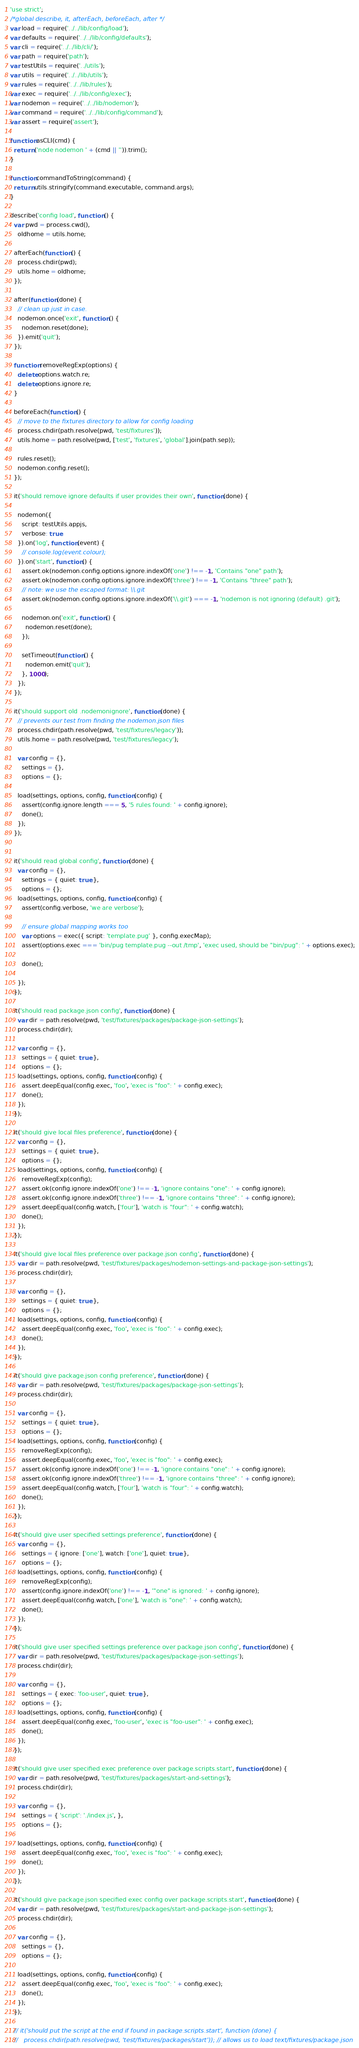Convert code to text. <code><loc_0><loc_0><loc_500><loc_500><_JavaScript_>'use strict';
/*global describe, it, afterEach, beforeEach, after */
var load = require('../../lib/config/load');
var defaults = require('../../lib/config/defaults');
var cli = require('../../lib/cli/');
var path = require('path');
var testUtils = require('../utils');
var utils = require('../../lib/utils');
var rules = require('../../lib/rules');
var exec = require('../../lib/config/exec');
var nodemon = require('../../lib/nodemon');
var command = require('../../lib/config/command');
var assert = require('assert');

function asCLI(cmd) {
  return ('node nodemon ' + (cmd || '')).trim();
}

function commandToString(command) {
  return utils.stringify(command.executable, command.args);
}

describe('config load', function () {
  var pwd = process.cwd(),
    oldhome = utils.home;

  afterEach(function () {
    process.chdir(pwd);
    utils.home = oldhome;
  });

  after(function (done) {
    // clean up just in case.
    nodemon.once('exit', function () {
      nodemon.reset(done);
    }).emit('quit');
  });

  function removeRegExp(options) {
    delete options.watch.re;
    delete options.ignore.re;
  }

  beforeEach(function () {
    // move to the fixtures directory to allow for config loading
    process.chdir(path.resolve(pwd, 'test/fixtures'));
    utils.home = path.resolve(pwd, ['test', 'fixtures', 'global'].join(path.sep));

    rules.reset();
    nodemon.config.reset();
  });

  it('should remove ignore defaults if user provides their own', function (done) {

    nodemon({
      script: testUtils.appjs,
      verbose: true
    }).on('log', function (event) {
      // console.log(event.colour);
    }).on('start', function () {
      assert.ok(nodemon.config.options.ignore.indexOf('one') !== -1, 'Contains "one" path');
      assert.ok(nodemon.config.options.ignore.indexOf('three') !== -1, 'Contains "three" path');
      // note: we use the escaped format: \\.git
      assert.ok(nodemon.config.options.ignore.indexOf('\\.git') === -1, 'nodemon is not ignoring (default) .git');

      nodemon.on('exit', function () {
        nodemon.reset(done);
      });

      setTimeout(function () {
        nodemon.emit('quit');
      }, 1000);
    });
  });

  it('should support old .nodemonignore', function (done) {
    // prevents our test from finding the nodemon.json files
    process.chdir(path.resolve(pwd, 'test/fixtures/legacy'));
    utils.home = path.resolve(pwd, 'test/fixtures/legacy');

    var config = {},
      settings = {},
      options = {};

    load(settings, options, config, function (config) {
      assert(config.ignore.length === 5, '5 rules found: ' + config.ignore);
      done();
    });
  });


  it('should read global config', function (done) {
    var config = {},
      settings = { quiet: true },
      options = {};
    load(settings, options, config, function (config) {
      assert(config.verbose, 'we are verbose');

      // ensure global mapping works too
      var options = exec({ script: 'template.pug' }, config.execMap);
      assert(options.exec === 'bin/pug template.pug --out /tmp', 'exec used, should be "bin/pug": ' + options.exec);

      done();

    });
  });

  it('should read package.json config', function (done) {
    var dir = path.resolve(pwd, 'test/fixtures/packages/package-json-settings');
    process.chdir(dir);

    var config = {},
      settings = { quiet: true },
      options = {};
    load(settings, options, config, function (config) {
      assert.deepEqual(config.exec, 'foo', 'exec is "foo": ' + config.exec);
      done();
    });
  });

  it('should give local files preference', function (done) {
    var config = {},
      settings = { quiet: true },
      options = {};
    load(settings, options, config, function (config) {
      removeRegExp(config);
      assert.ok(config.ignore.indexOf('one') !== -1, 'ignore contains "one": ' + config.ignore);
      assert.ok(config.ignore.indexOf('three') !== -1, 'ignore contains "three": ' + config.ignore);
      assert.deepEqual(config.watch, ['four'], 'watch is "four": ' + config.watch);
      done();
    });
  });

  it('should give local files preference over package.json config', function (done) {
    var dir = path.resolve(pwd, 'test/fixtures/packages/nodemon-settings-and-package-json-settings');
    process.chdir(dir);

    var config = {},
      settings = { quiet: true },
      options = {};
    load(settings, options, config, function (config) {
      assert.deepEqual(config.exec, 'foo', 'exec is "foo": ' + config.exec);
      done();
    });
  });

  it('should give package.json config preference', function (done) {
    var dir = path.resolve(pwd, 'test/fixtures/packages/package-json-settings');
    process.chdir(dir);

    var config = {},
      settings = { quiet: true },
      options = {};
    load(settings, options, config, function (config) {
      removeRegExp(config);
      assert.deepEqual(config.exec, 'foo', 'exec is "foo": ' + config.exec);
      assert.ok(config.ignore.indexOf('one') !== -1, 'ignore contains "one": ' + config.ignore);
      assert.ok(config.ignore.indexOf('three') !== -1, 'ignore contains "three": ' + config.ignore);
      assert.deepEqual(config.watch, ['four'], 'watch is "four": ' + config.watch);
      done();
    });
  });

  it('should give user specified settings preference', function (done) {
    var config = {},
      settings = { ignore: ['one'], watch: ['one'], quiet: true },
      options = {};
    load(settings, options, config, function (config) {
      removeRegExp(config);
      assert(config.ignore.indexOf('one') !== -1, '"one" is ignored: ' + config.ignore);
      assert.deepEqual(config.watch, ['one'], 'watch is "one": ' + config.watch);
      done();
    });
  });

  it('should give user specified settings preference over package.json config', function (done) {
    var dir = path.resolve(pwd, 'test/fixtures/packages/package-json-settings');
    process.chdir(dir);

    var config = {},
      settings = { exec: 'foo-user', quiet: true },
      options = {};
    load(settings, options, config, function (config) {
      assert.deepEqual(config.exec, 'foo-user', 'exec is "foo-user": ' + config.exec);
      done();
    });
  });

  it('should give user specified exec preference over package.scripts.start', function (done) {
    var dir = path.resolve(pwd, 'test/fixtures/packages/start-and-settings');
    process.chdir(dir);

    var config = {},
      settings = { 'script': './index.js', },
      options = {};

    load(settings, options, config, function (config) {
      assert.deepEqual(config.exec, 'foo', 'exec is "foo": ' + config.exec);
      done();
    });
  });

  it('should give package.json specified exec config over package.scripts.start', function (done) {
    var dir = path.resolve(pwd, 'test/fixtures/packages/start-and-package-json-settings');
    process.chdir(dir);

    var config = {},
      settings = {},
      options = {};

    load(settings, options, config, function (config) {
      assert.deepEqual(config.exec, 'foo', 'exec is "foo": ' + config.exec);
      done();
    });
  });

  // it('should put the script at the end if found in package.scripts.start', function (done) {
  //   process.chdir(path.resolve(pwd, 'test/fixtures/packages/start')); // allows us to load text/fixtures/package.json</code> 